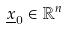Convert formula to latex. <formula><loc_0><loc_0><loc_500><loc_500>\underline { x } _ { 0 } \in \mathbb { R } ^ { n }</formula> 